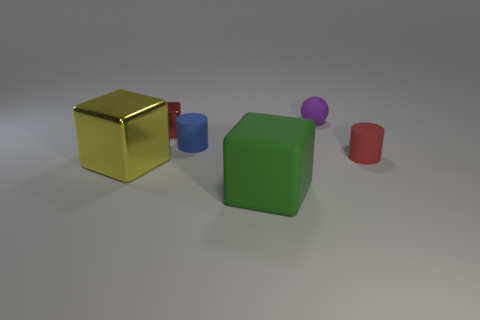Subtract all large blocks. How many blocks are left? 1 Subtract all red cylinders. How many cylinders are left? 1 Add 2 big blue cylinders. How many objects exist? 8 Subtract all cylinders. How many objects are left? 4 Subtract 2 blocks. How many blocks are left? 1 Add 1 big green things. How many big green things are left? 2 Add 4 yellow metal objects. How many yellow metal objects exist? 5 Subtract 1 green blocks. How many objects are left? 5 Subtract all blue blocks. Subtract all brown spheres. How many blocks are left? 3 Subtract all brown balls. How many blue cylinders are left? 1 